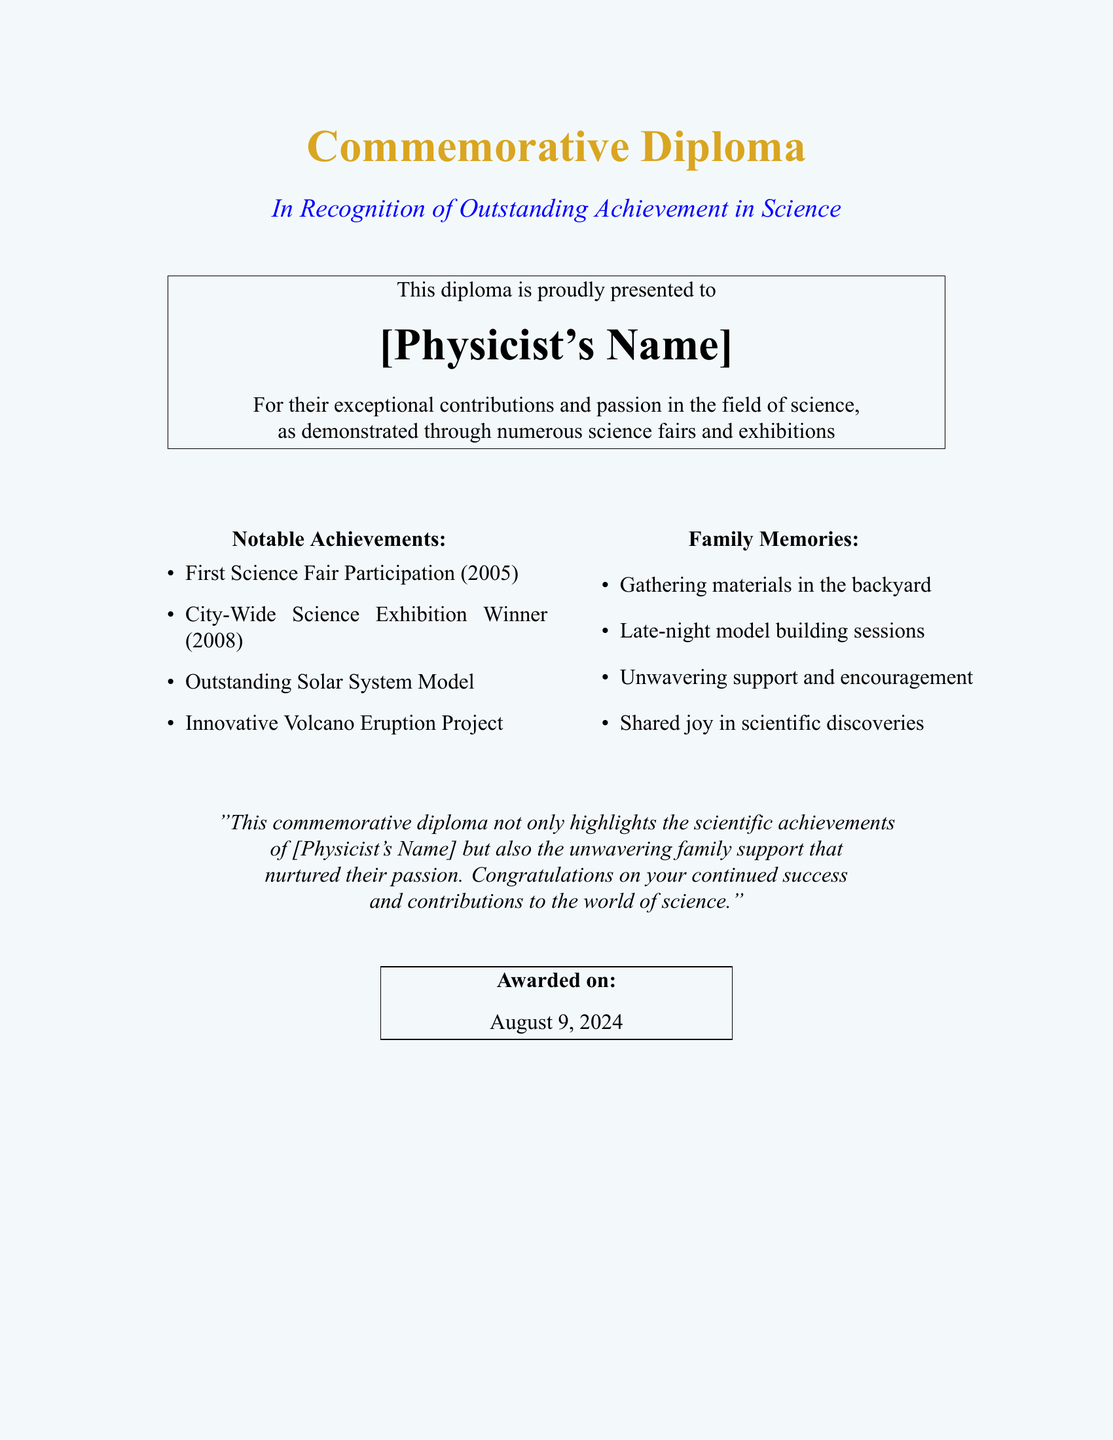What is the title of the diploma? The title of the diploma is written at the top in large text.
Answer: Commemorative Diploma Who is the diploma presented to? The diploma includes a section where the recipient's name is mentioned in bold.
Answer: [Physicist's Name] In what year did the first science fair participation occur? The notable achievements section lists the year directly associated with the first participation.
Answer: 2005 What award did the physicist win in 2008? The notable achievements section specifies the event and year.
Answer: City-Wide Science Exhibition Winner What project is noted for its innovation? The notable achievements section highlights specific projects and their significance.
Answer: Innovative Volcano Eruption Project What type of support is highlighted in the family memories? The family memories section reflects the nature of support provided.
Answer: Unwavering support and encouragement What is the significance of the diploma stated in the concluding sentence? The conclusion summarizes the essence of the diploma's intention and recognition.
Answer: Highlights the scientific achievements and family support On what date is the diploma awarded? The diploma specifies the award date at the end of the document.
Answer: Today 